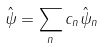Convert formula to latex. <formula><loc_0><loc_0><loc_500><loc_500>\hat { \psi } = \sum _ { n } c _ { n } \hat { \psi } _ { n }</formula> 